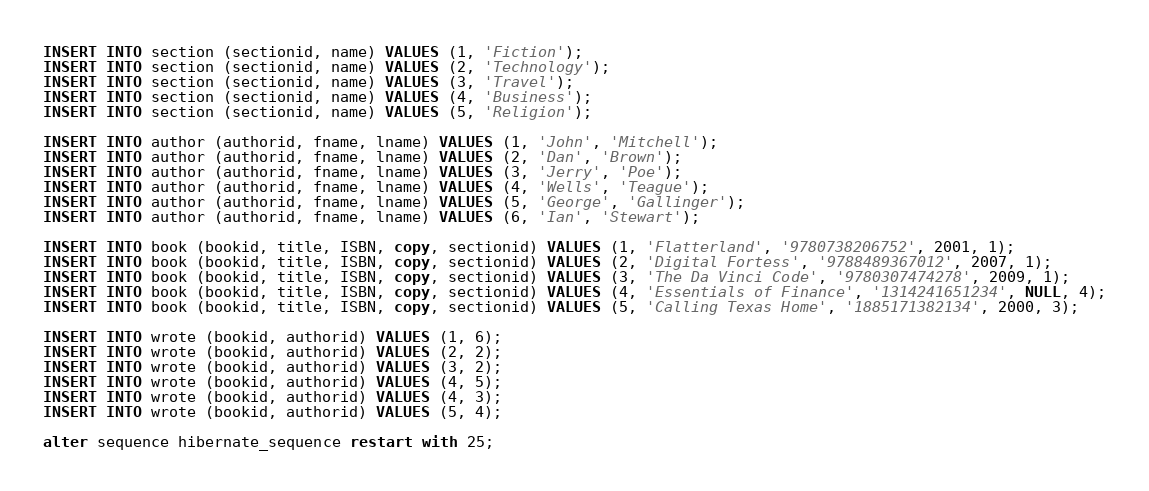Convert code to text. <code><loc_0><loc_0><loc_500><loc_500><_SQL_>INSERT INTO section (sectionid, name) VALUES (1, 'Fiction');
INSERT INTO section (sectionid, name) VALUES (2, 'Technology');
INSERT INTO section (sectionid, name) VALUES (3, 'Travel');
INSERT INTO section (sectionid, name) VALUES (4, 'Business');
INSERT INTO section (sectionid, name) VALUES (5, 'Religion');

INSERT INTO author (authorid, fname, lname) VALUES (1, 'John', 'Mitchell');
INSERT INTO author (authorid, fname, lname) VALUES (2, 'Dan', 'Brown');
INSERT INTO author (authorid, fname, lname) VALUES (3, 'Jerry', 'Poe');
INSERT INTO author (authorid, fname, lname) VALUES (4, 'Wells', 'Teague');
INSERT INTO author (authorid, fname, lname) VALUES (5, 'George', 'Gallinger');
INSERT INTO author (authorid, fname, lname) VALUES (6, 'Ian', 'Stewart');

INSERT INTO book (bookid, title, ISBN, copy, sectionid) VALUES (1, 'Flatterland', '9780738206752', 2001, 1);
INSERT INTO book (bookid, title, ISBN, copy, sectionid) VALUES (2, 'Digital Fortess', '9788489367012', 2007, 1);
INSERT INTO book (bookid, title, ISBN, copy, sectionid) VALUES (3, 'The Da Vinci Code', '9780307474278', 2009, 1);
INSERT INTO book (bookid, title, ISBN, copy, sectionid) VALUES (4, 'Essentials of Finance', '1314241651234', NULL, 4);
INSERT INTO book (bookid, title, ISBN, copy, sectionid) VALUES (5, 'Calling Texas Home', '1885171382134', 2000, 3);

INSERT INTO wrote (bookid, authorid) VALUES (1, 6);
INSERT INTO wrote (bookid, authorid) VALUES (2, 2);
INSERT INTO wrote (bookid, authorid) VALUES (3, 2);
INSERT INTO wrote (bookid, authorid) VALUES (4, 5);
INSERT INTO wrote (bookid, authorid) VALUES (4, 3);
INSERT INTO wrote (bookid, authorid) VALUES (5, 4);

alter sequence hibernate_sequence restart with 25;
</code> 